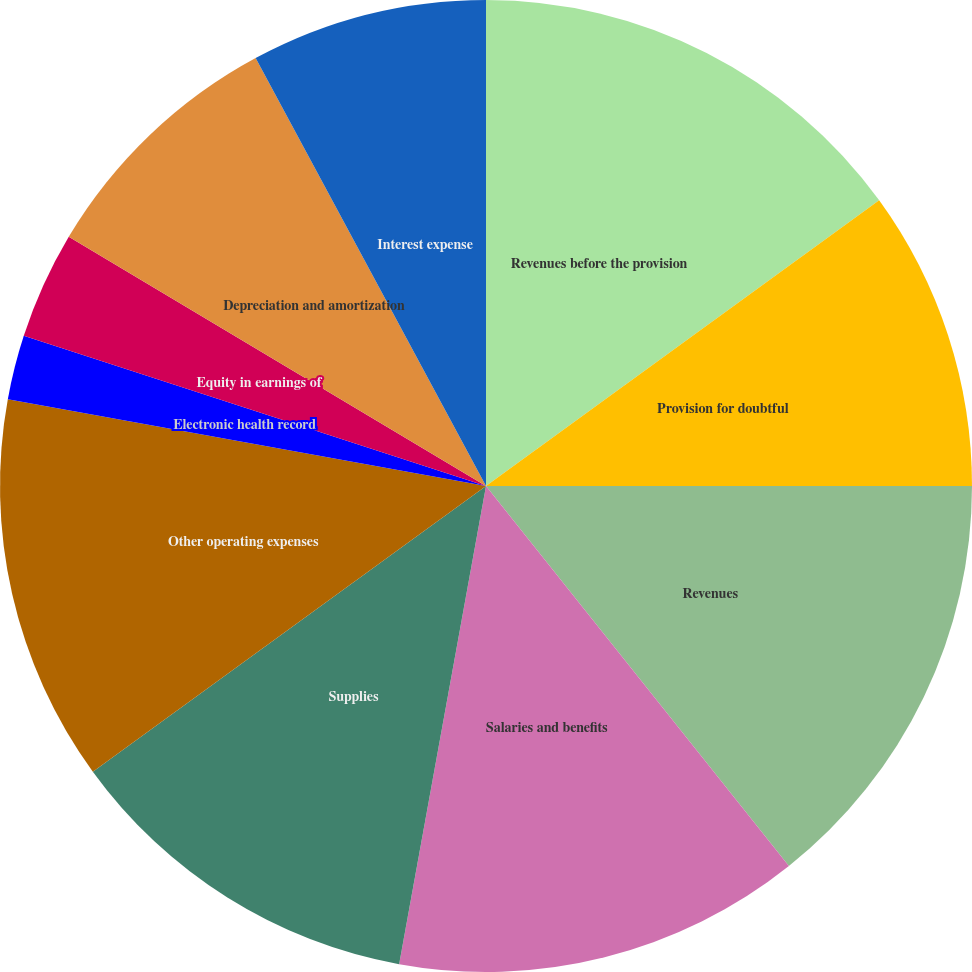Convert chart to OTSL. <chart><loc_0><loc_0><loc_500><loc_500><pie_chart><fcel>Revenues before the provision<fcel>Provision for doubtful<fcel>Revenues<fcel>Salaries and benefits<fcel>Supplies<fcel>Other operating expenses<fcel>Electronic health record<fcel>Equity in earnings of<fcel>Depreciation and amortization<fcel>Interest expense<nl><fcel>15.0%<fcel>10.0%<fcel>14.29%<fcel>13.57%<fcel>12.14%<fcel>12.86%<fcel>2.14%<fcel>3.57%<fcel>8.57%<fcel>7.86%<nl></chart> 